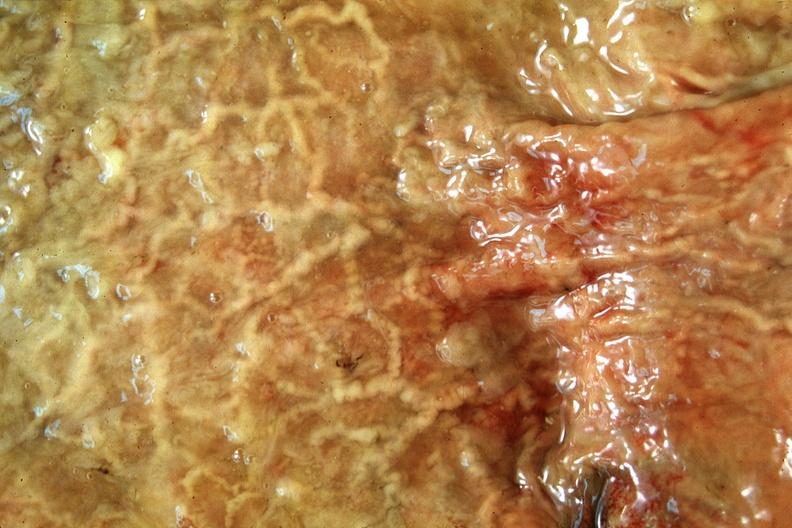s there present?
Answer the question using a single word or phrase. No 